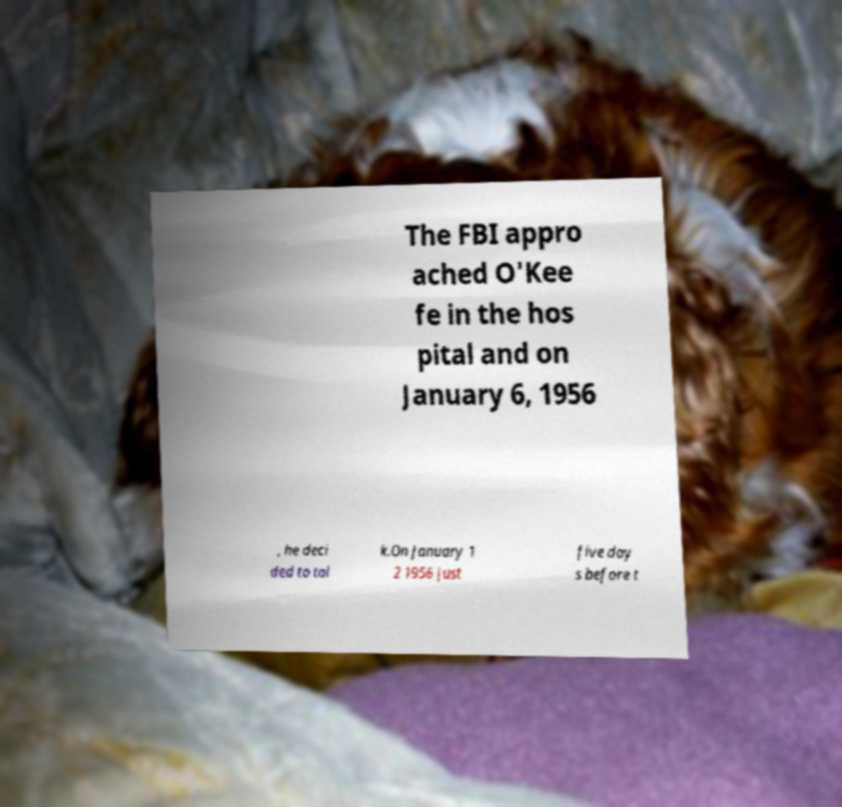Please read and relay the text visible in this image. What does it say? The FBI appro ached O'Kee fe in the hos pital and on January 6, 1956 , he deci ded to tal k.On January 1 2 1956 just five day s before t 